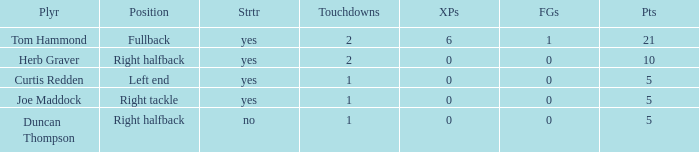Name the most touchdowns for field goals being 1 2.0. 